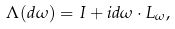Convert formula to latex. <formula><loc_0><loc_0><loc_500><loc_500>\Lambda ( d \omega ) = I + i d \omega \cdot L _ { \omega } ,</formula> 